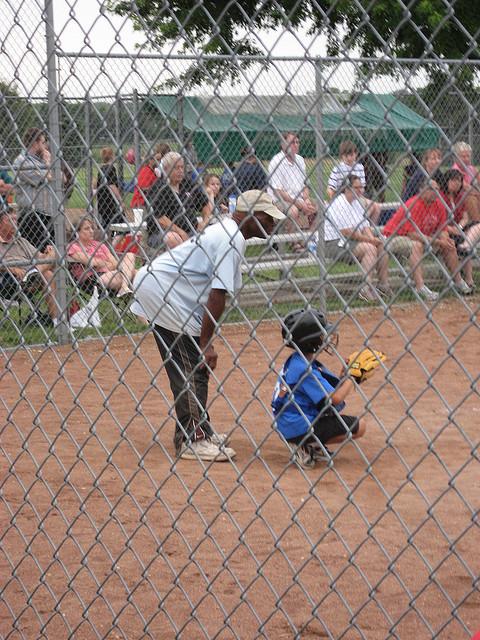Does the team have uniforms?
Give a very brief answer. No. How many humans can you count?
Quick response, please. 12. What position is the boy with the mitt playing?
Write a very short answer. Catcher. Is this boy the shortest person in the photo?
Keep it brief. Yes. How many men are wearing hats?
Write a very short answer. 1. How many people are standing on the dirt?
Keep it brief. 2. 